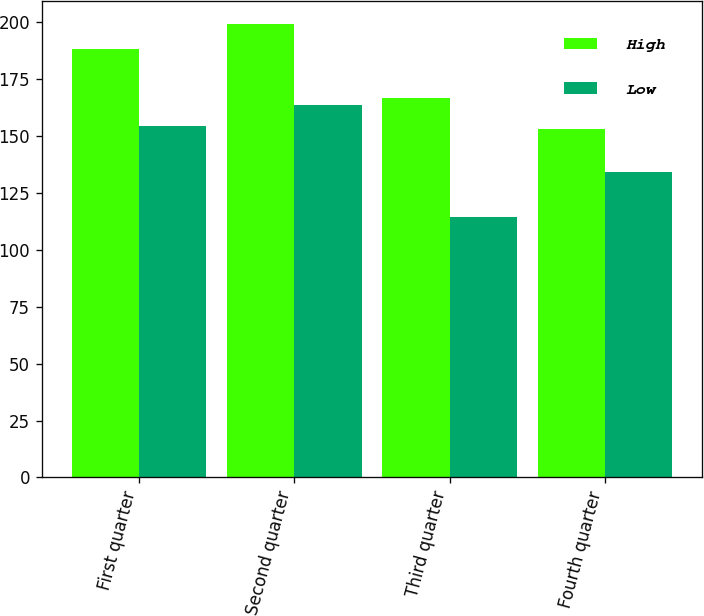Convert chart to OTSL. <chart><loc_0><loc_0><loc_500><loc_500><stacked_bar_chart><ecel><fcel>First quarter<fcel>Second quarter<fcel>Third quarter<fcel>Fourth quarter<nl><fcel>High<fcel>188.43<fcel>199.43<fcel>166.78<fcel>153.07<nl><fcel>Low<fcel>154.33<fcel>163.57<fcel>114.53<fcel>134.17<nl></chart> 